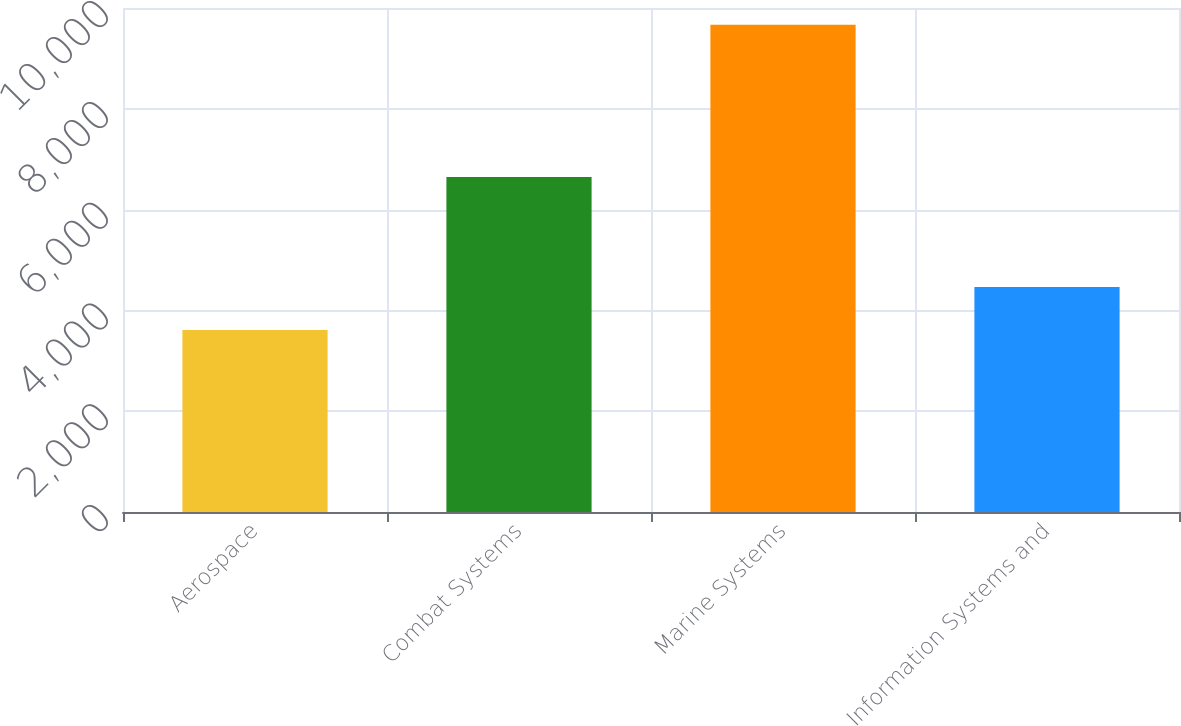Convert chart. <chart><loc_0><loc_0><loc_500><loc_500><bar_chart><fcel>Aerospace<fcel>Combat Systems<fcel>Marine Systems<fcel>Information Systems and<nl><fcel>3610<fcel>6649<fcel>9670<fcel>4462<nl></chart> 